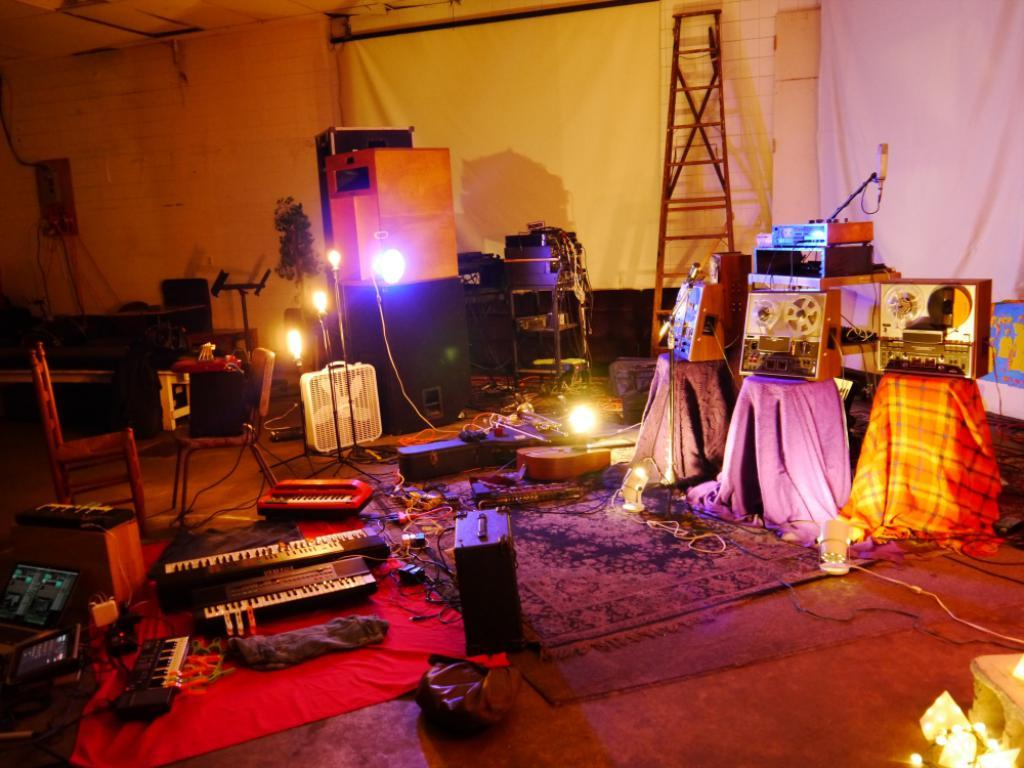What type of objects are present in the image that are related to music? There are musical instruments in the image. What devices are used for recording in the image? There are tape recorders in the image. What special effects can be seen in the image? There are lasers in the image. What can be seen providing illumination in the image? There are lights in the image. Can you describe any other items in the room besides the musical instruments, tape recorders, lasers, and lights? There are other items in the room, but their specific details are not mentioned in the provided facts. What type of bag is needed to carry the musical instruments in the image? There is no mention of a bag in the image, and the specific type of bag needed would depend on the size and number of musical instruments. 